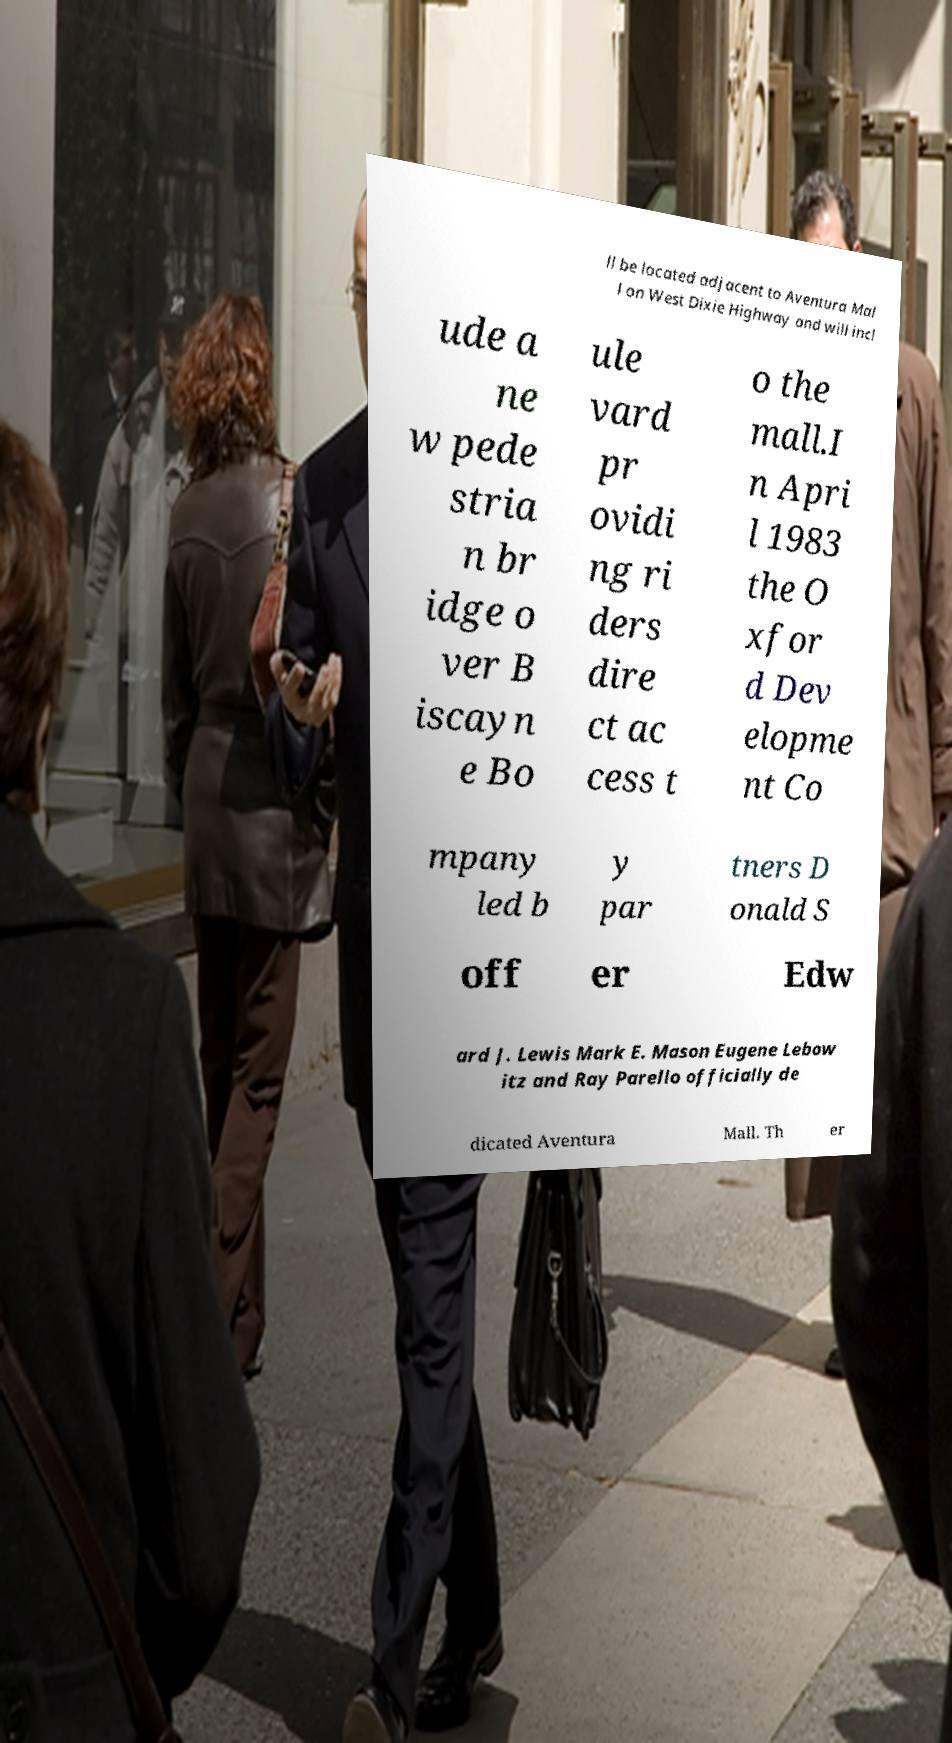Please identify and transcribe the text found in this image. ll be located adjacent to Aventura Mal l on West Dixie Highway and will incl ude a ne w pede stria n br idge o ver B iscayn e Bo ule vard pr ovidi ng ri ders dire ct ac cess t o the mall.I n Apri l 1983 the O xfor d Dev elopme nt Co mpany led b y par tners D onald S off er Edw ard J. Lewis Mark E. Mason Eugene Lebow itz and Ray Parello officially de dicated Aventura Mall. Th er 